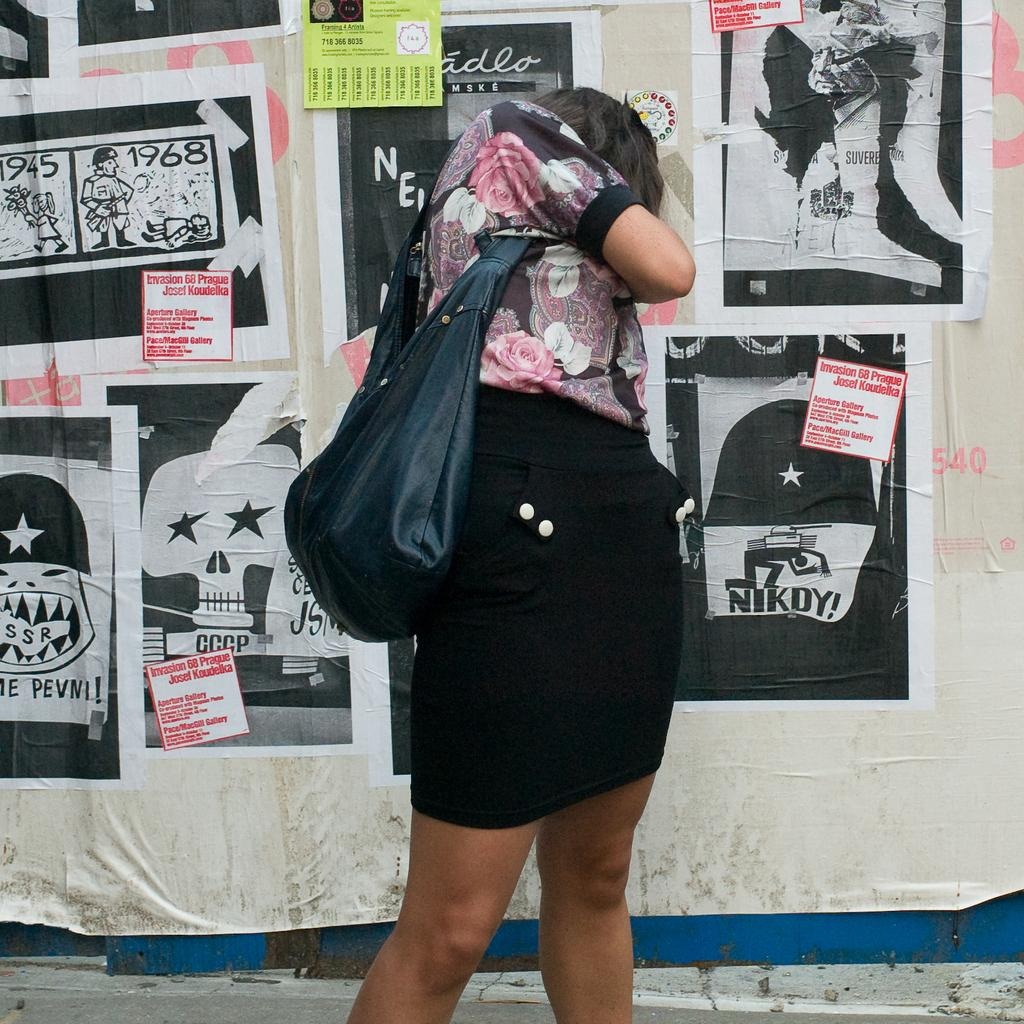What is the main subject in the image? There is a woman standing in the image. Can you describe what the woman is wearing? The woman is wearing a bag. What can be seen on the wall in the image? There are different types of posters on the wall in the image. How many houses are visible in the image? There are no houses visible in the image; it features a woman standing and posters on the wall. Does the woman in the image express any hate towards someone or something? There is no indication of hate expressed by the woman in the image. 